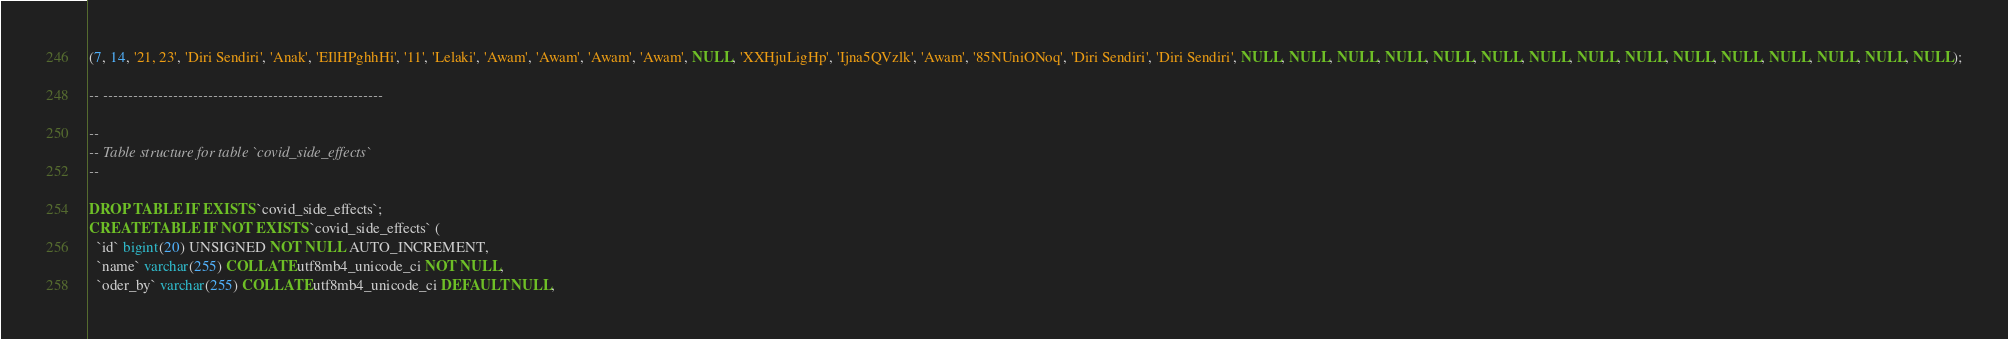<code> <loc_0><loc_0><loc_500><loc_500><_SQL_>(7, 14, '21, 23', 'Diri Sendiri', 'Anak', 'EIlHPghhHi', '11', 'Lelaki', 'Awam', 'Awam', 'Awam', 'Awam', NULL, 'XXHjuLigHp', 'Ijna5QVzlk', 'Awam', '85NUniONoq', 'Diri Sendiri', 'Diri Sendiri', NULL, NULL, NULL, NULL, NULL, NULL, NULL, NULL, NULL, NULL, NULL, NULL, NULL, NULL, NULL);

-- --------------------------------------------------------

--
-- Table structure for table `covid_side_effects`
--

DROP TABLE IF EXISTS `covid_side_effects`;
CREATE TABLE IF NOT EXISTS `covid_side_effects` (
  `id` bigint(20) UNSIGNED NOT NULL AUTO_INCREMENT,
  `name` varchar(255) COLLATE utf8mb4_unicode_ci NOT NULL,
  `oder_by` varchar(255) COLLATE utf8mb4_unicode_ci DEFAULT NULL,</code> 